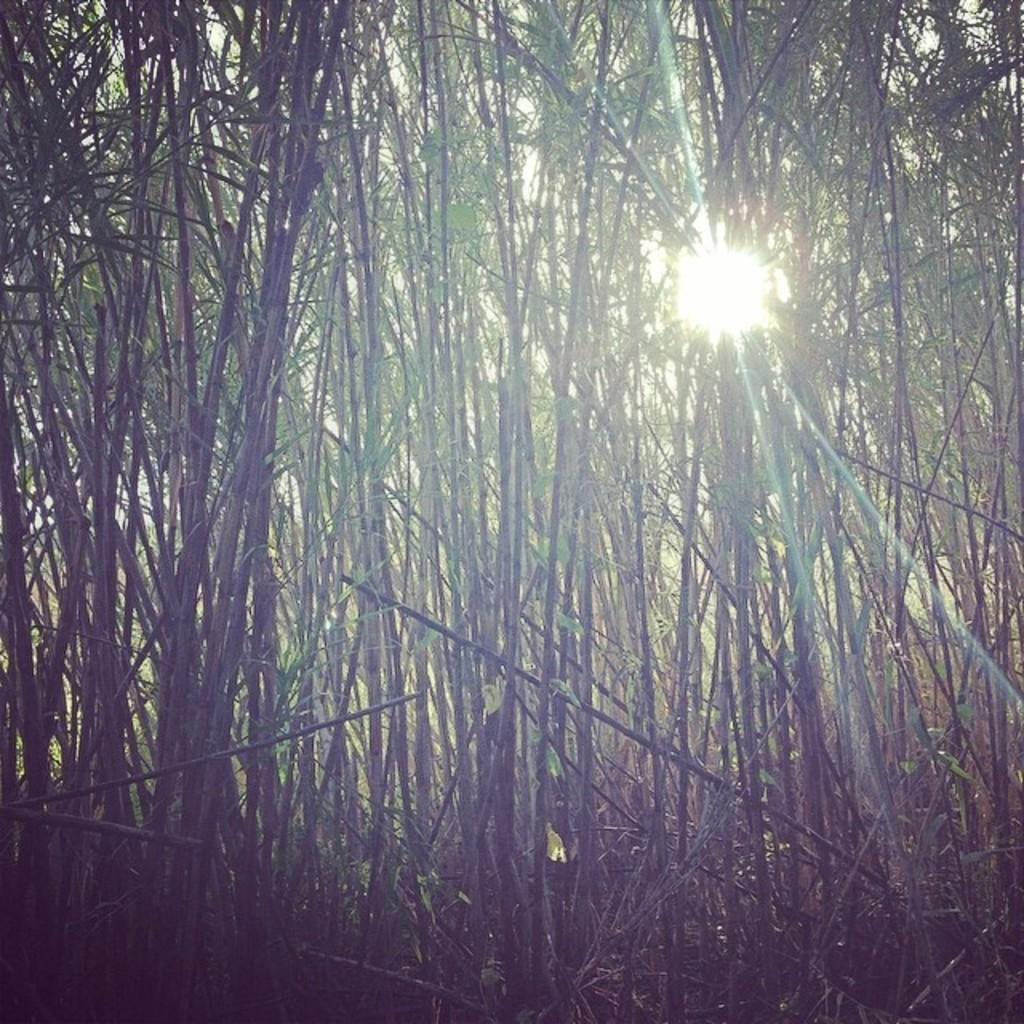What type of vegetation can be seen in the image? There are trees in the image. What natural light source is visible in the image? There is sunlight visible in the image. How many snails can be seen crawling on the trees in the image? There are no snails visible on the trees in the image. What type of impulse can be observed in the sunlight in the image? There is no impulse present in the sunlight in the image; it is simply a natural light source. 